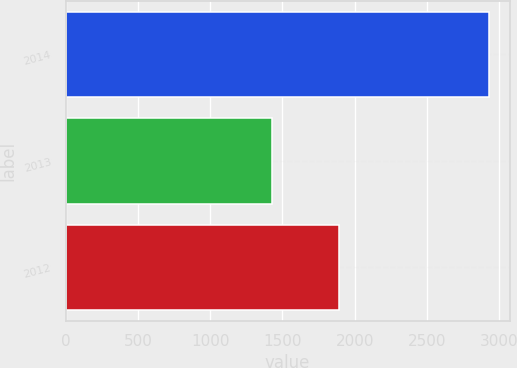Convert chart. <chart><loc_0><loc_0><loc_500><loc_500><bar_chart><fcel>2014<fcel>2013<fcel>2012<nl><fcel>2926<fcel>1430<fcel>1893<nl></chart> 